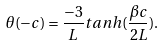<formula> <loc_0><loc_0><loc_500><loc_500>\theta ( - c ) = \frac { - 3 } { L } t a n h ( \frac { \beta c } { 2 L } ) .</formula> 